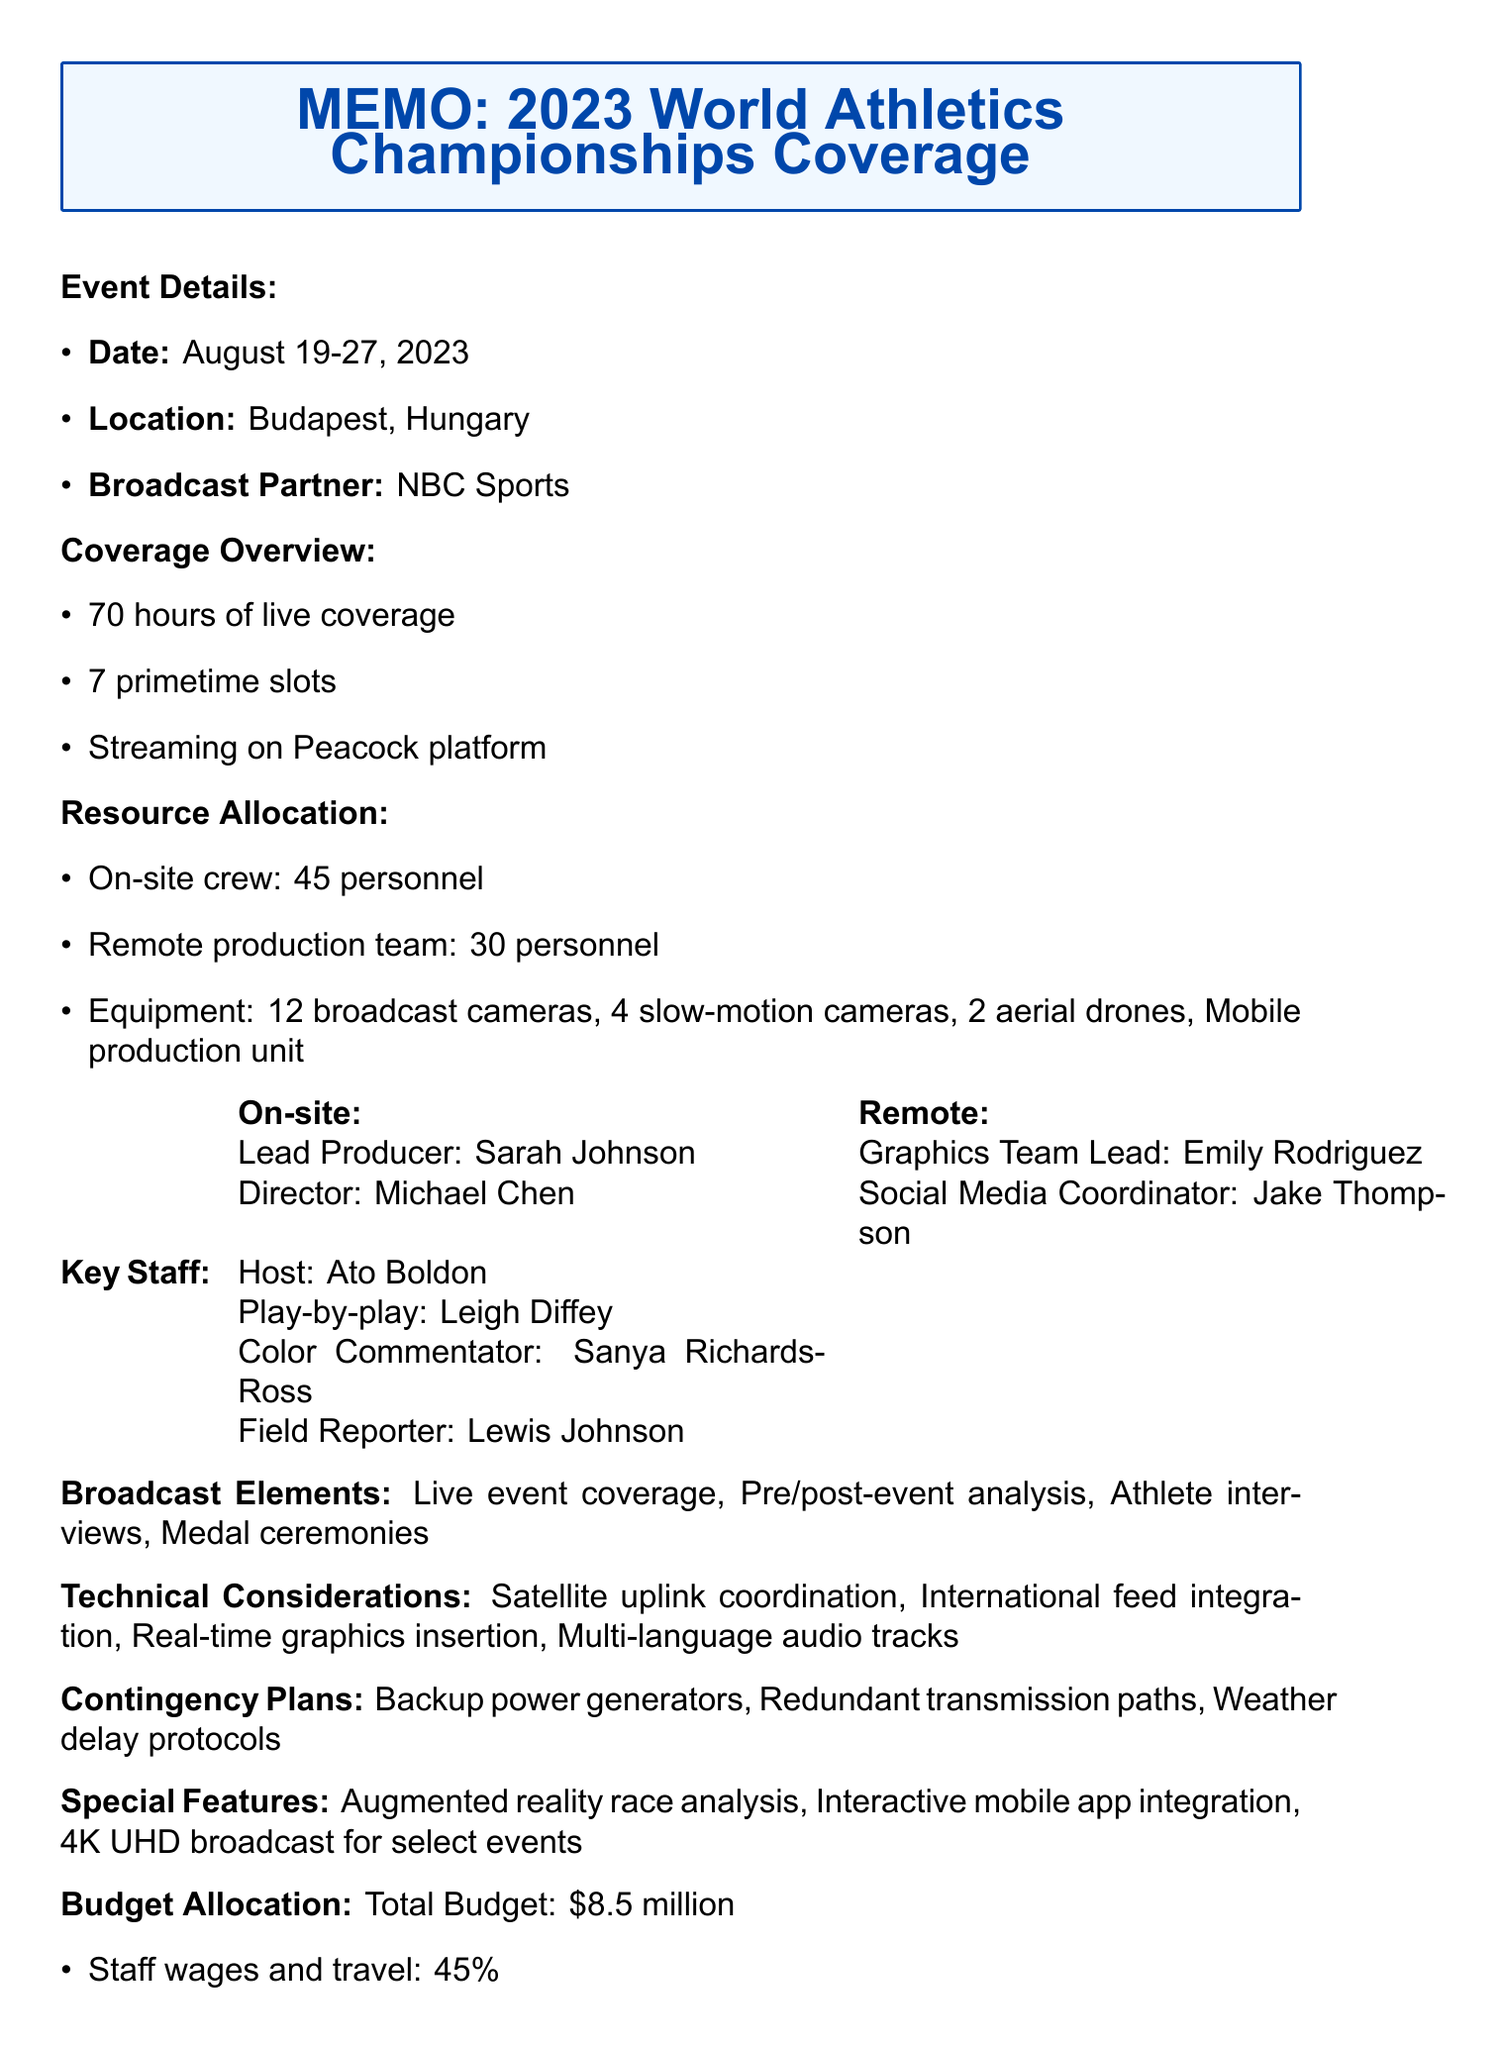What is the event name? The event name is explicitly stated in the document as “2023 World Athletics Championships.”
Answer: 2023 World Athletics Championships How many hours of live coverage are planned? The document specifies that there will be 70 hours of live coverage for the event.
Answer: 70 hours Who is the host for this event? The document lists Ato Boldon as the host, which is a specific role mentioned under on-site staffing.
Answer: Ato Boldon What is the total budget for the event? The document details a total budget amounting to $8.5 million.
Answer: $8.5 million What percentage of the budget is allocated to staff wages and travel? The allocation for staff wages and travel is mentioned as 45% of the total budget in the document.
Answer: 45% How many personnel are on the on-site crew? The document states that there are 45 personnel on the on-site crew for the event.
Answer: 45 What special feature involves augmented reality? The document specifically mentions “Augmented reality race analysis” as one of the special features planned for the event.
Answer: Augmented reality race analysis What are the post-event deliverables mentioned? The document lists highlight packages, digital content for social media, and an analytics report as post-event deliverables.
Answer: Highlight packages for news broadcasts, digital content for social media platforms, analytics report on viewership and engagement 